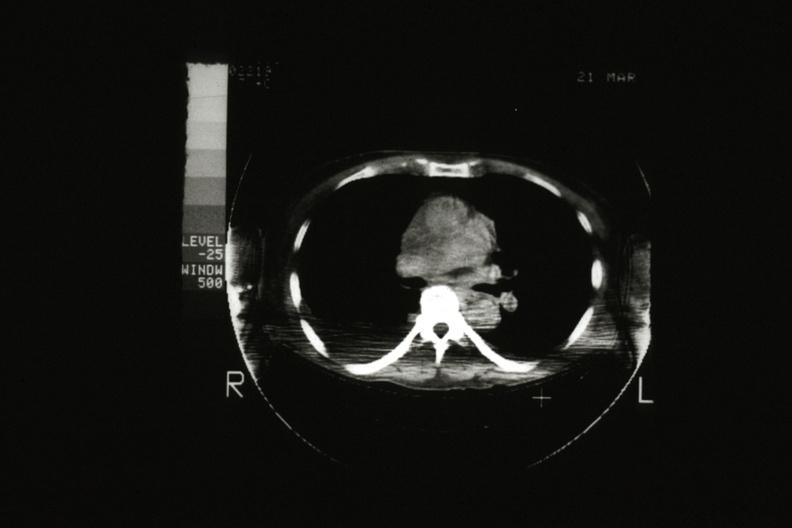does villous adenoma show cat scan showing tumor mass invading superior vena ca?
Answer the question using a single word or phrase. No 